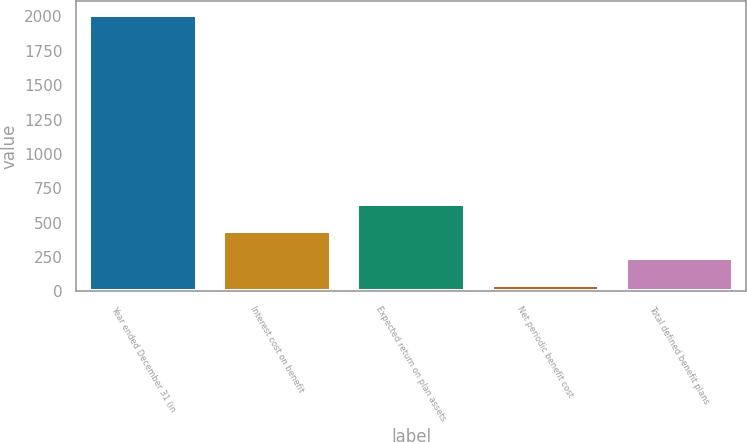<chart> <loc_0><loc_0><loc_500><loc_500><bar_chart><fcel>Year ended December 31 (in<fcel>Interest cost on benefit<fcel>Expected return on plan assets<fcel>Net periodic benefit cost<fcel>Total defined benefit plans<nl><fcel>2008<fcel>439.2<fcel>635.3<fcel>47<fcel>243.1<nl></chart> 